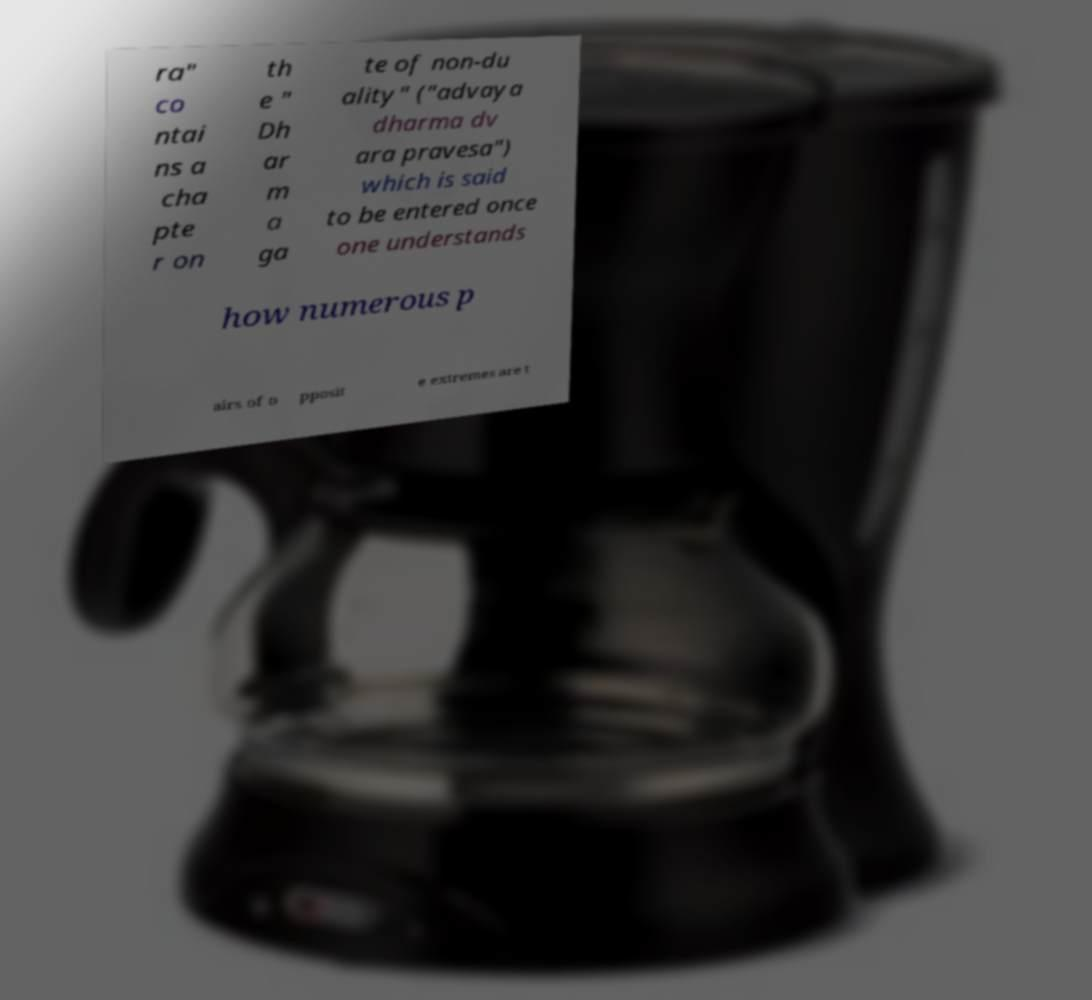Please identify and transcribe the text found in this image. ra" co ntai ns a cha pte r on th e " Dh ar m a ga te of non-du ality" ("advaya dharma dv ara pravesa") which is said to be entered once one understands how numerous p airs of o pposit e extremes are t 